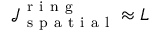<formula> <loc_0><loc_0><loc_500><loc_500>\mathcal { J } _ { s p a t i a l } ^ { r i n g } \approx L</formula> 